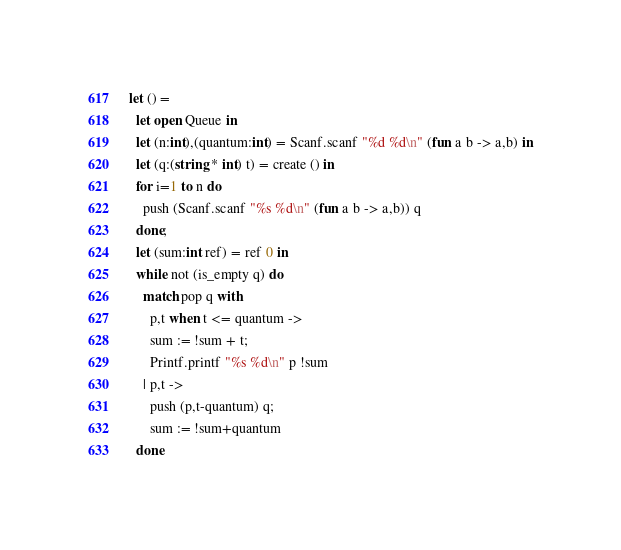<code> <loc_0><loc_0><loc_500><loc_500><_OCaml_>let () =
  let open Queue in
  let (n:int),(quantum:int) = Scanf.scanf "%d %d\n" (fun a b -> a,b) in
  let (q:(string * int) t) = create () in
  for i=1 to n do
    push (Scanf.scanf "%s %d\n" (fun a b -> a,b)) q
  done;
  let (sum:int ref) = ref 0 in
  while not (is_empty q) do
    match pop q with
      p,t when t <= quantum ->
      sum := !sum + t;
      Printf.printf "%s %d\n" p !sum
    | p,t ->
      push (p,t-quantum) q;
      sum := !sum+quantum
  done</code> 